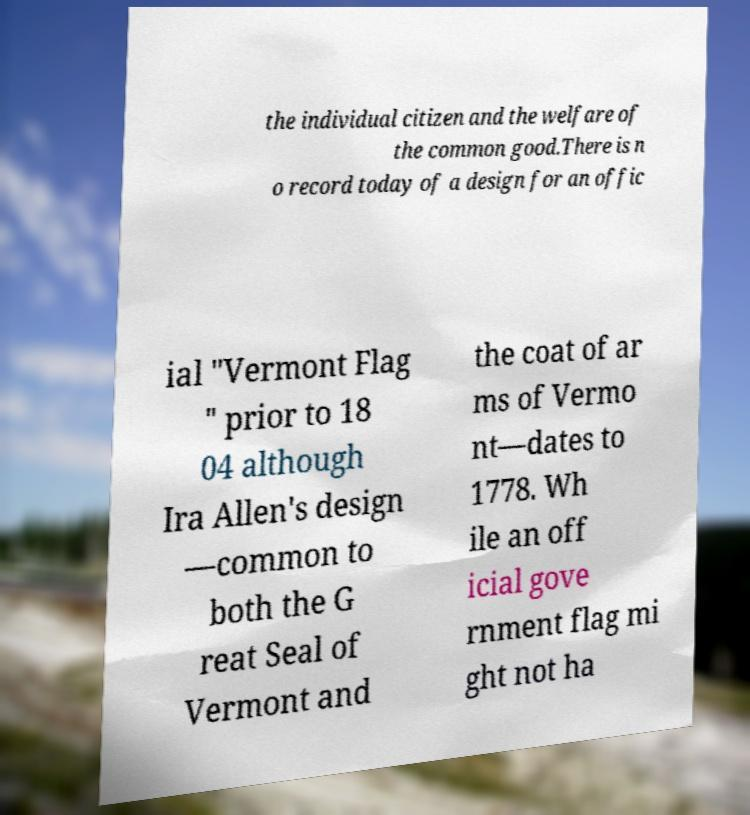Please identify and transcribe the text found in this image. the individual citizen and the welfare of the common good.There is n o record today of a design for an offic ial "Vermont Flag " prior to 18 04 although Ira Allen's design —common to both the G reat Seal of Vermont and the coat of ar ms of Vermo nt—dates to 1778. Wh ile an off icial gove rnment flag mi ght not ha 